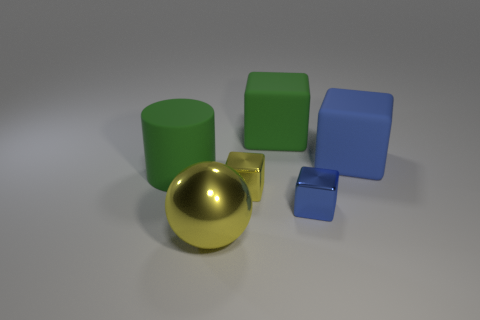Does the blue object behind the big green rubber cylinder have the same shape as the green matte object that is right of the shiny ball?
Your response must be concise. Yes. How many things are either blue shiny cubes or blue things on the left side of the blue matte object?
Provide a succinct answer. 1. How many other objects are there of the same shape as the large yellow object?
Ensure brevity in your answer.  0. Is the material of the big green object on the right side of the large metallic object the same as the green cylinder?
Offer a very short reply. Yes. How many objects are matte objects or blue blocks?
Provide a short and direct response. 4. What size is the other blue thing that is the same shape as the big blue rubber thing?
Ensure brevity in your answer.  Small. What size is the blue matte block?
Ensure brevity in your answer.  Large. Are there more large green matte cubes in front of the large blue rubber cube than small yellow things?
Keep it short and to the point. No. Is there any other thing that has the same material as the green block?
Offer a very short reply. Yes. Is the color of the big thing in front of the big cylinder the same as the big rubber object that is on the left side of the large yellow shiny thing?
Your answer should be compact. No. 